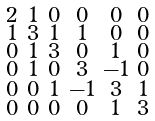<formula> <loc_0><loc_0><loc_500><loc_500>\begin{smallmatrix} 2 & 1 & 0 & 0 & 0 & 0 \\ 1 & 3 & 1 & 1 & 0 & 0 \\ 0 & 1 & 3 & 0 & 1 & 0 \\ 0 & 1 & 0 & 3 & - 1 & 0 \\ 0 & 0 & 1 & - 1 & 3 & 1 \\ 0 & 0 & 0 & 0 & 1 & 3 \end{smallmatrix}</formula> 